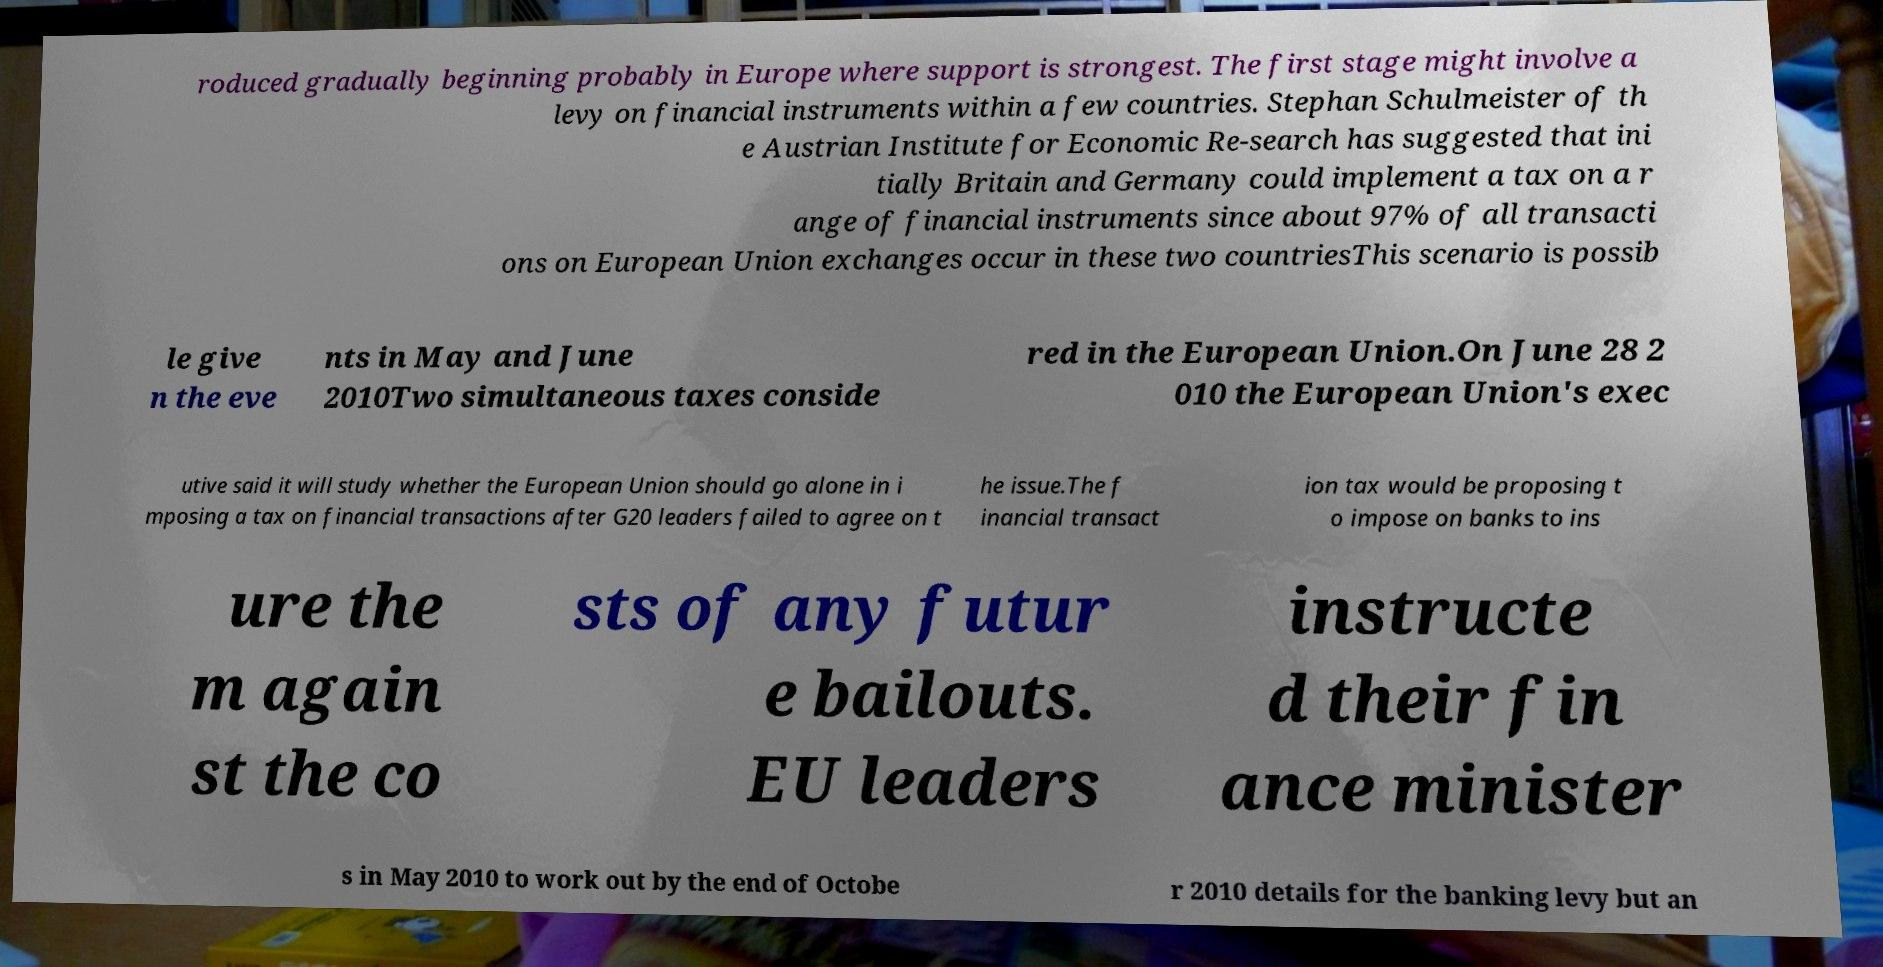Could you extract and type out the text from this image? roduced gradually beginning probably in Europe where support is strongest. The first stage might involve a levy on financial instruments within a few countries. Stephan Schulmeister of th e Austrian Institute for Economic Re-search has suggested that ini tially Britain and Germany could implement a tax on a r ange of financial instruments since about 97% of all transacti ons on European Union exchanges occur in these two countriesThis scenario is possib le give n the eve nts in May and June 2010Two simultaneous taxes conside red in the European Union.On June 28 2 010 the European Union's exec utive said it will study whether the European Union should go alone in i mposing a tax on financial transactions after G20 leaders failed to agree on t he issue.The f inancial transact ion tax would be proposing t o impose on banks to ins ure the m again st the co sts of any futur e bailouts. EU leaders instructe d their fin ance minister s in May 2010 to work out by the end of Octobe r 2010 details for the banking levy but an 